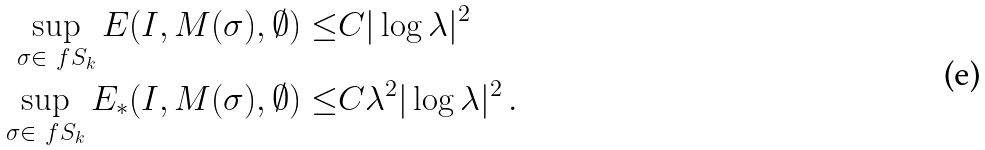Convert formula to latex. <formula><loc_0><loc_0><loc_500><loc_500>\sup _ { \sigma \in \ f S _ { k } } E ( I , M ( \sigma ) , \emptyset ) \leq & C | \log \lambda | ^ { 2 } \\ \sup _ { \sigma \in \ f S _ { k } } E _ { * } ( I , M ( \sigma ) , \emptyset ) \leq & C \lambda ^ { 2 } | \log \lambda | ^ { 2 } \, .</formula> 